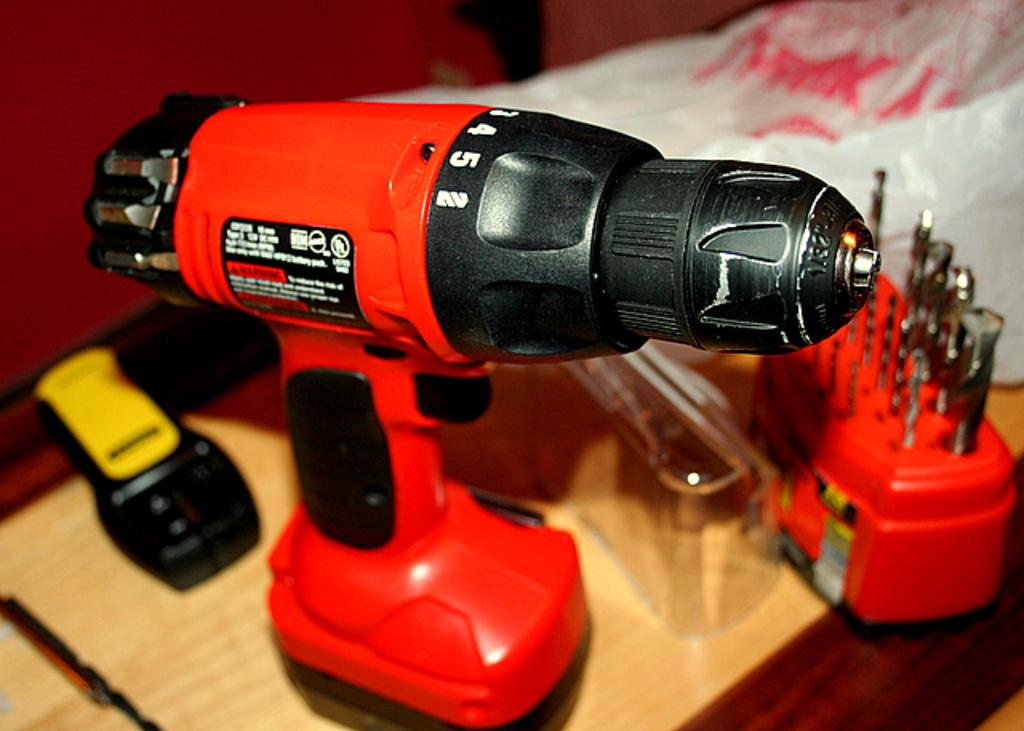What is the main object in the center of the image? There is a table in the center of the image. What tool is on the table? A handheld power drill is on the table. What type of cover is on the table? A plastic cover is on the table. What device is on the table? A remote is on the table. What colored box is on the table? A red box is on the table. Are there any other objects on the table? Yes, there are a few other objects on the table. What type of zinc is visible in the image? There is no zinc present in the image. Can you see any clouds in the image? The image does not show any clouds; it is focused on objects on a table. 